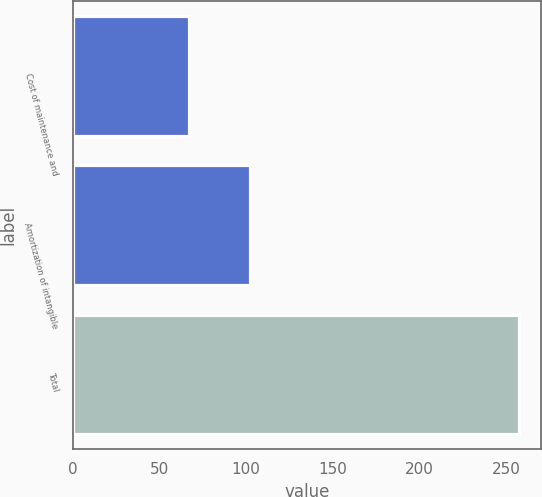Convert chart. <chart><loc_0><loc_0><loc_500><loc_500><bar_chart><fcel>Cost of maintenance and<fcel>Amortization of intangible<fcel>Total<nl><fcel>67<fcel>102.2<fcel>257.2<nl></chart> 